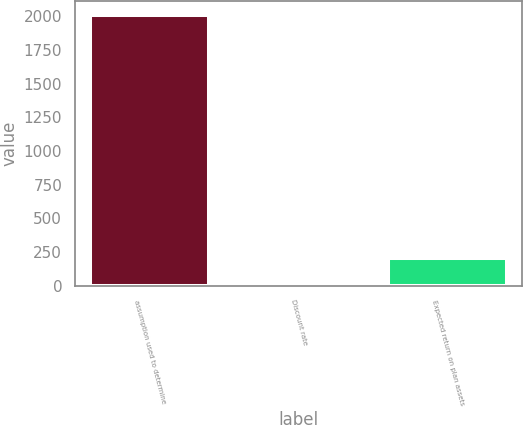Convert chart to OTSL. <chart><loc_0><loc_0><loc_500><loc_500><bar_chart><fcel>assumption used to determine<fcel>Discount rate<fcel>Expected return on plan assets<nl><fcel>2009<fcel>6.11<fcel>206.4<nl></chart> 